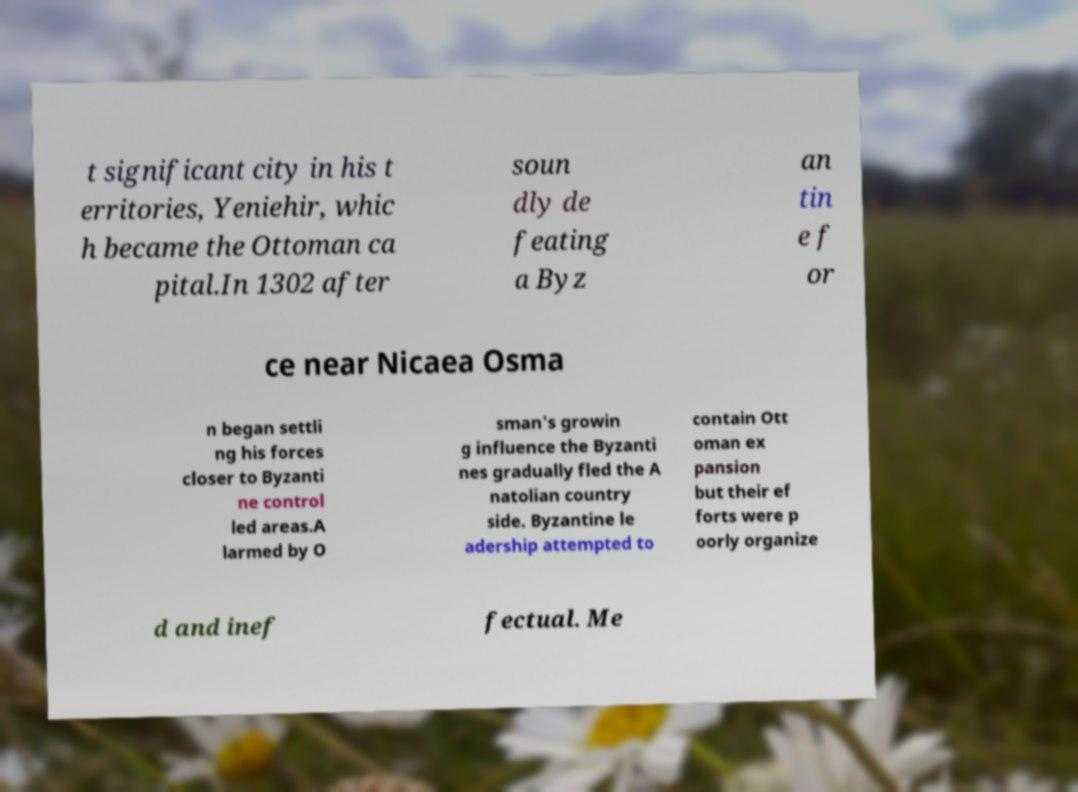Can you explain the significance of the year 1302 in the context of this text? The year 1302 marks a significant moment for the Ottoman Empire as it references a key victory for Osman I, the empire's founder, over a Byzantine force near Nicaea. This victory was crucial in establishing Ottoman dominance and influence in the region, leading to the eventual decline of Byzantine control and setting the stage for the empire's expansion. 